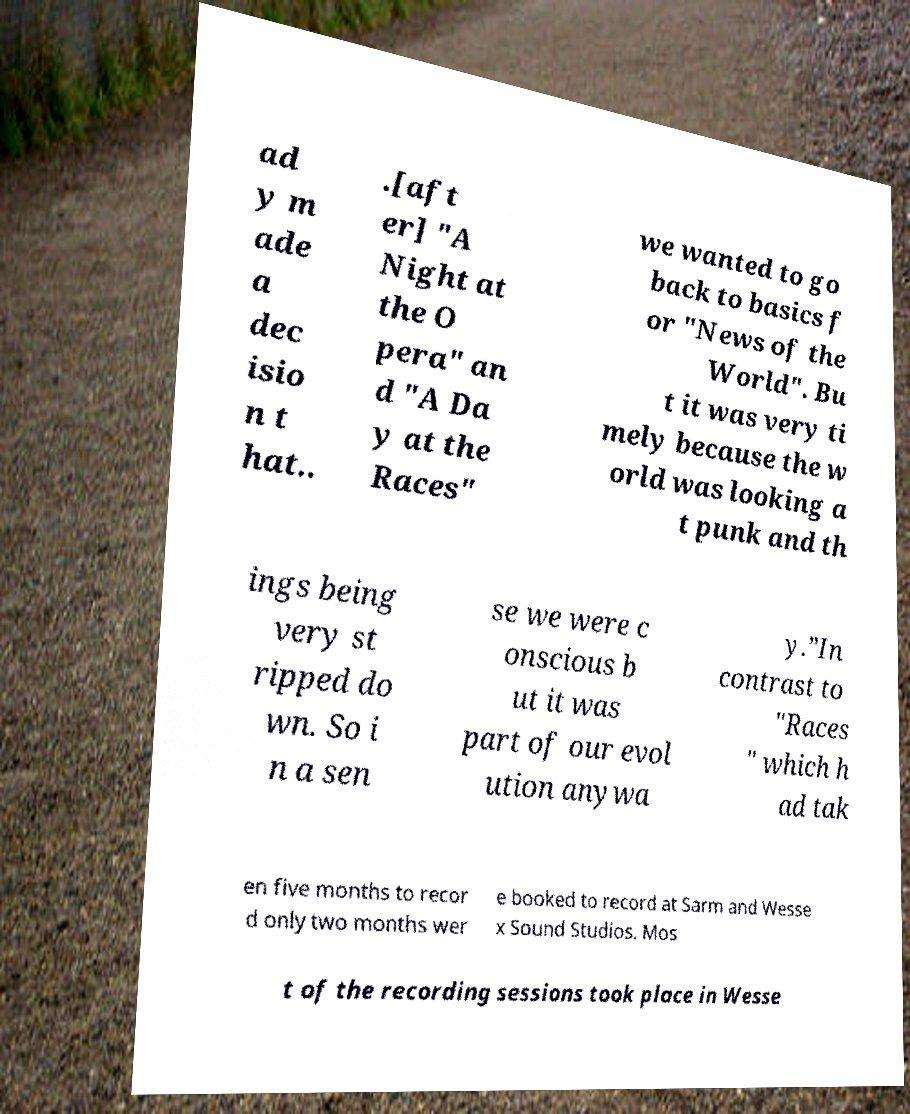There's text embedded in this image that I need extracted. Can you transcribe it verbatim? ad y m ade a dec isio n t hat.. .[aft er] "A Night at the O pera" an d "A Da y at the Races" we wanted to go back to basics f or "News of the World". Bu t it was very ti mely because the w orld was looking a t punk and th ings being very st ripped do wn. So i n a sen se we were c onscious b ut it was part of our evol ution anywa y.”In contrast to "Races " which h ad tak en five months to recor d only two months wer e booked to record at Sarm and Wesse x Sound Studios. Mos t of the recording sessions took place in Wesse 